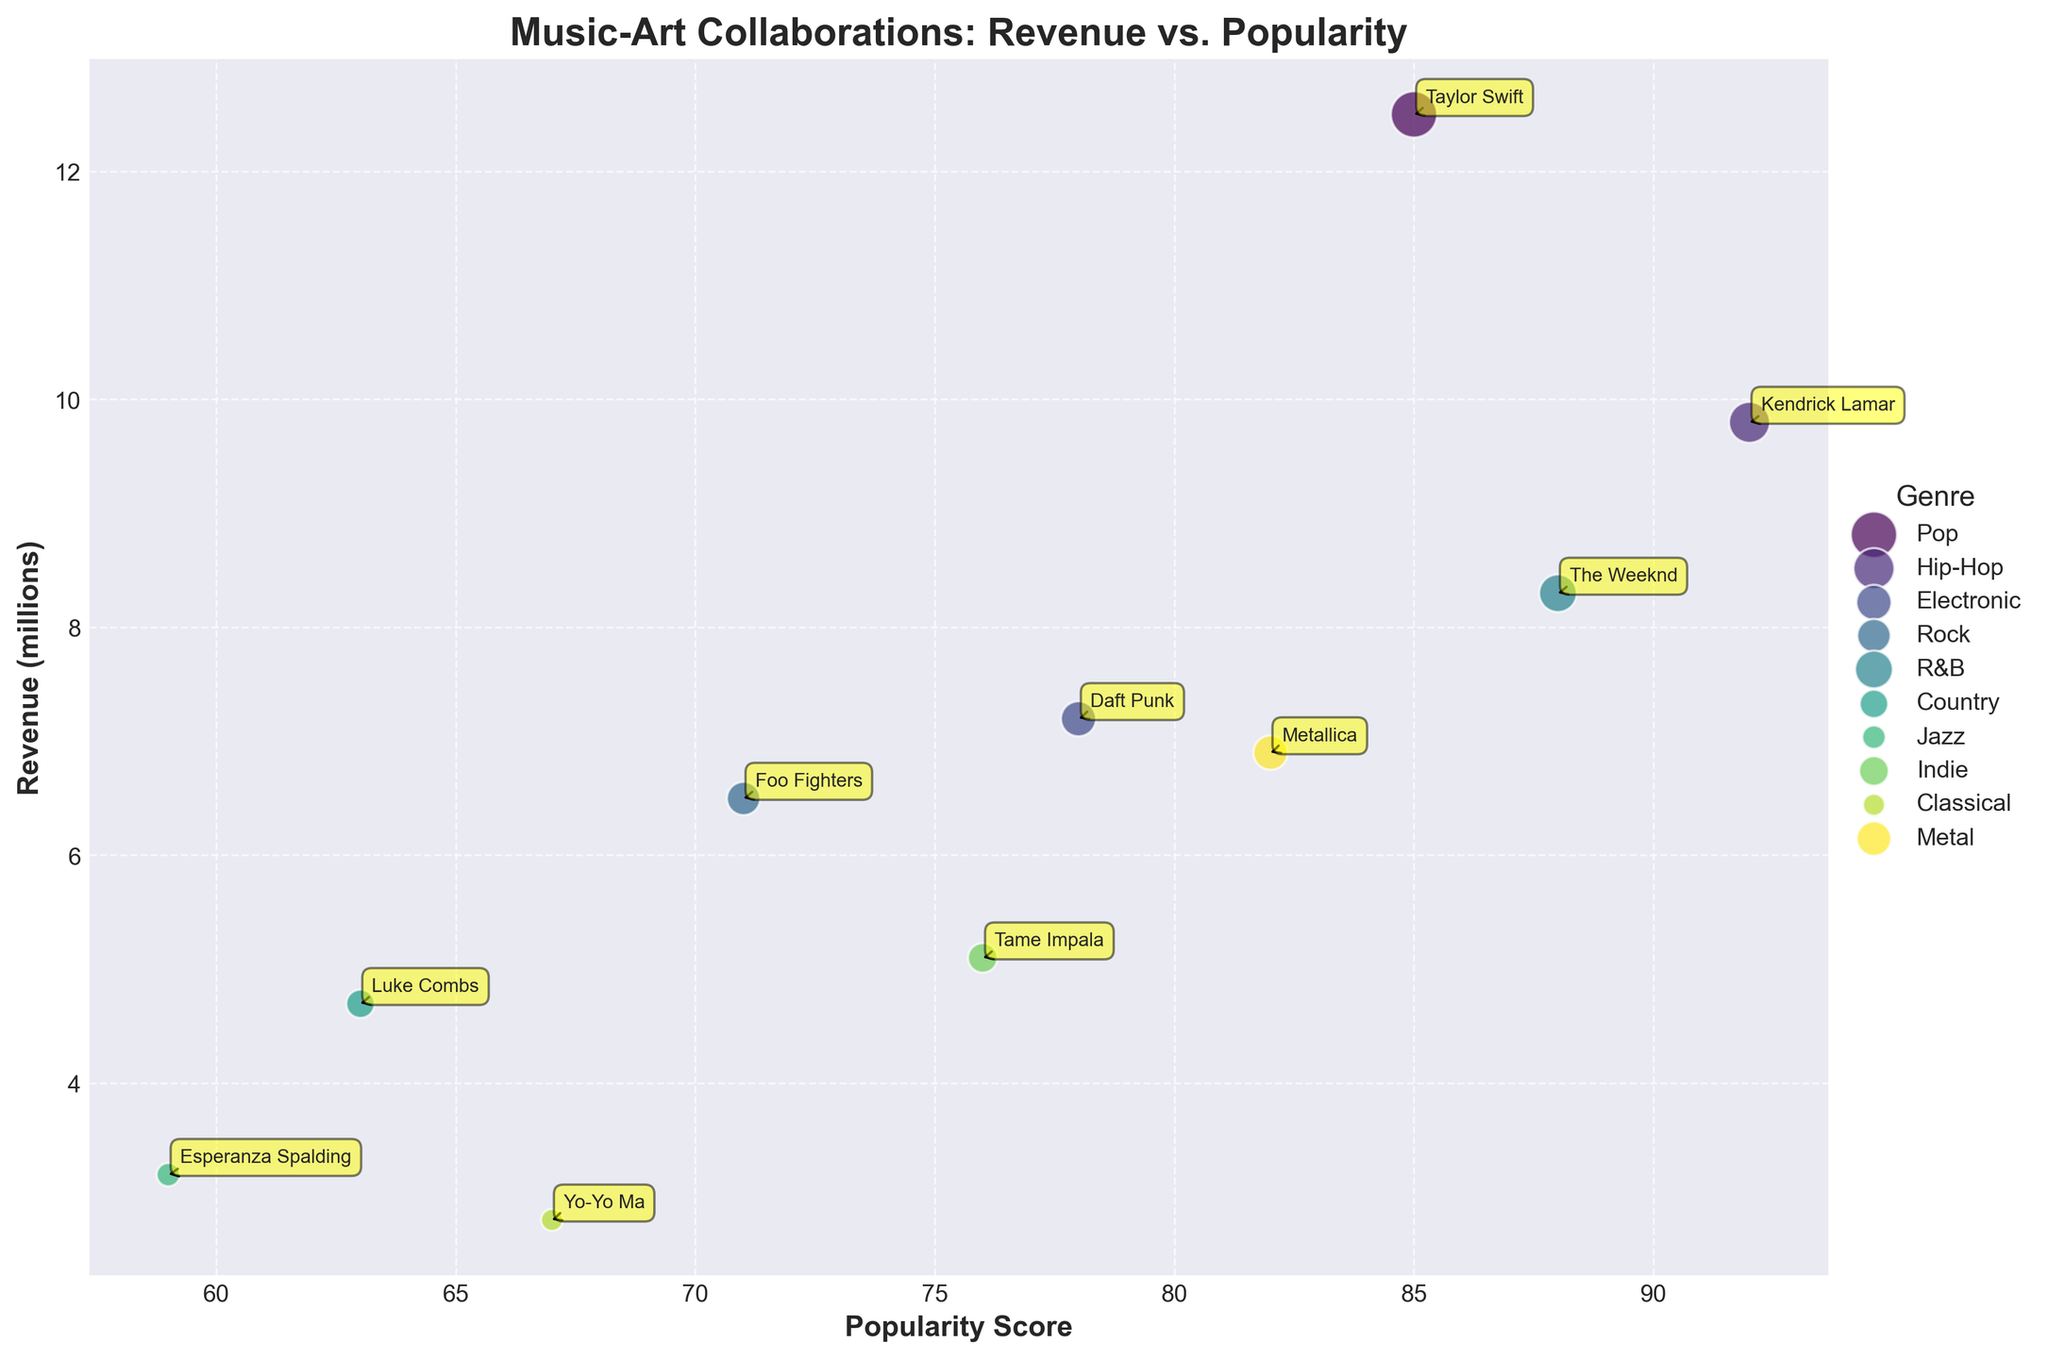what is the genre with the highest revenue collaboration? To determine the genre with the highest revenue collaboration, observe the color-coded genre groups. Identify the bubble with the maximum size, and look at the label to find the genre.
Answer: Pop what is the title of the figure? To find the title of the figure, look above the subplot where titles are typically placed.
Answer: Music-Art Collaborations: Revenue vs. Popularity which collaboration has the highest popularity score? Look for the bubble positioned furthest to the right on the x-axis, as this represents the highest popularity score. Then, read the label next to this bubble.
Answer: Kendrick Lamar x Banksy what’s the average revenue of the Hip-Hop collaborations? First, identify all the Hip-Hop collaboration bubbles. Sum their revenues and divide by the number of Hip-Hop collaborations. (9.8)
Answer: 9.8 what is the number of collaborations falling under the 'Electronic' genre? Count the number of bubbles associated with the 'Electronic' label based on the color-coded legend.
Answer: 1 are there more collaborations in the 'Pop' genre or the 'Rock' genre? Compare the number of bubbles that fall under 'Pop' vs. 'Rock' based on the color-coded legend.
Answer: Equal which collaboration had a higher revenue: 'The Weeknd x Yayoi Kusama' or 'Metallica x H.R. Giger'? Compare the size of the bubbles for 'The Weeknd x Yayoi Kusama' and 'Metallica x H.R. Giger'. Determine which is larger.
Answer: Metallica x H.R. Giger What’s the genre of the collaboration 'Tame Impala x Takashi Murakami'? Locate the bubble labeled 'Tame Impala x Takashi Murakami' and use the color-coding to link it to its genre in the legend.
Answer: Indie how much revenue did the 'Country' genre generate in the depicted collaborations? Identify the 'Country' genre bubble and read its associated revenue.
Answer: 4.7 which genre shows a collaboration with the lowest popularity score? Locate the bubble furthest to the left on the x-axis and determine its genre through color-coding and the legend.
Answer: Jazz 